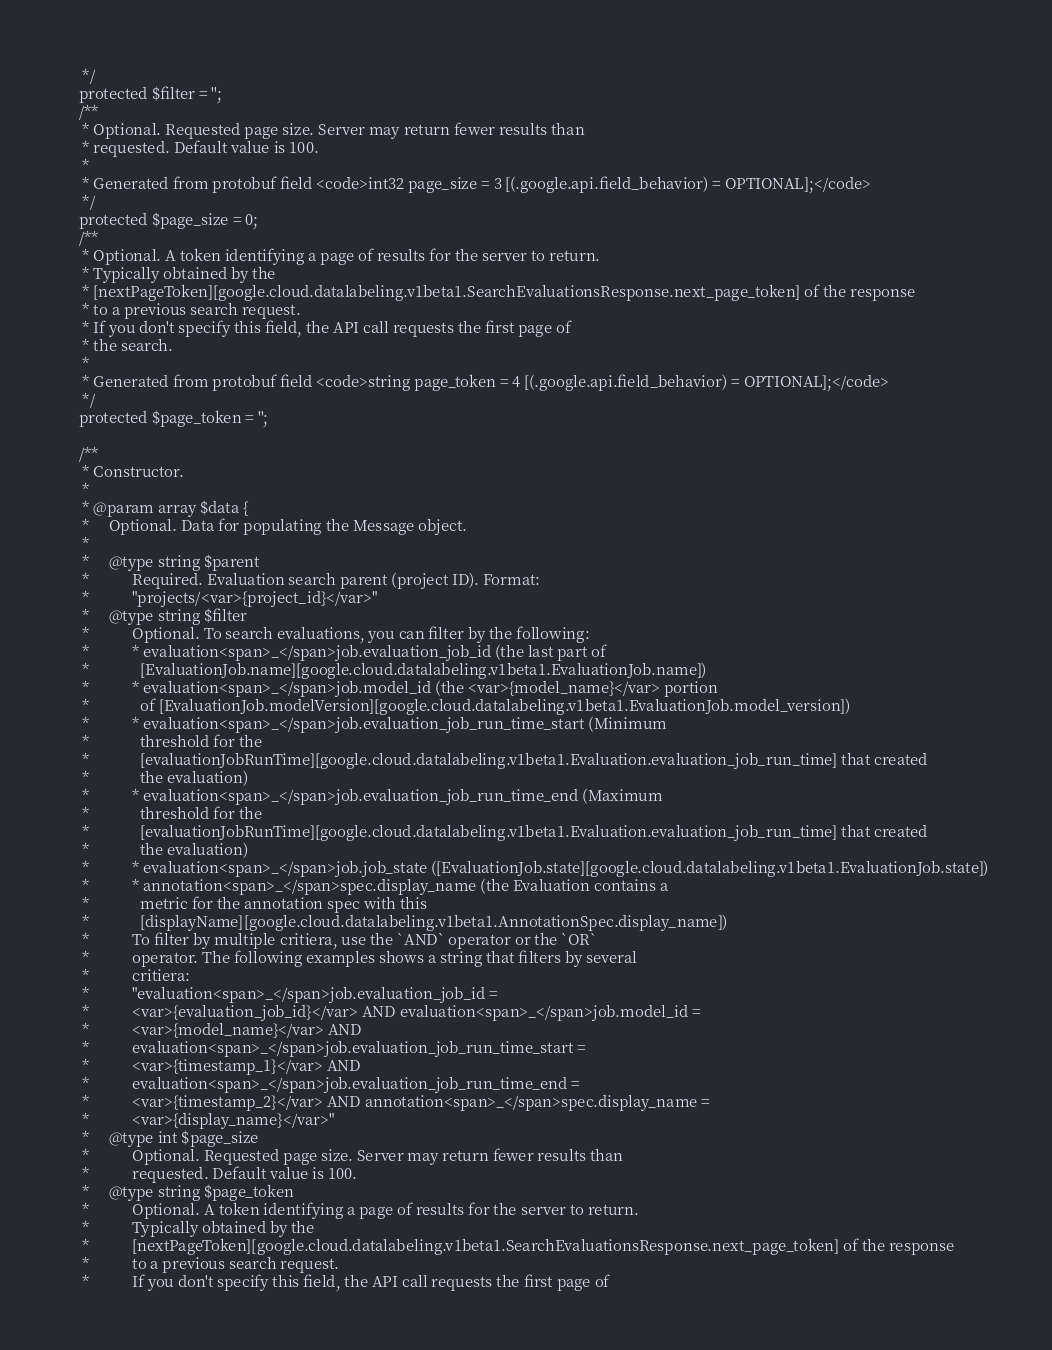Convert code to text. <code><loc_0><loc_0><loc_500><loc_500><_PHP_>     */
    protected $filter = '';
    /**
     * Optional. Requested page size. Server may return fewer results than
     * requested. Default value is 100.
     *
     * Generated from protobuf field <code>int32 page_size = 3 [(.google.api.field_behavior) = OPTIONAL];</code>
     */
    protected $page_size = 0;
    /**
     * Optional. A token identifying a page of results for the server to return.
     * Typically obtained by the
     * [nextPageToken][google.cloud.datalabeling.v1beta1.SearchEvaluationsResponse.next_page_token] of the response
     * to a previous search request.
     * If you don't specify this field, the API call requests the first page of
     * the search.
     *
     * Generated from protobuf field <code>string page_token = 4 [(.google.api.field_behavior) = OPTIONAL];</code>
     */
    protected $page_token = '';

    /**
     * Constructor.
     *
     * @param array $data {
     *     Optional. Data for populating the Message object.
     *
     *     @type string $parent
     *           Required. Evaluation search parent (project ID). Format:
     *           "projects/<var>{project_id}</var>"
     *     @type string $filter
     *           Optional. To search evaluations, you can filter by the following:
     *           * evaluation<span>_</span>job.evaluation_job_id (the last part of
     *             [EvaluationJob.name][google.cloud.datalabeling.v1beta1.EvaluationJob.name])
     *           * evaluation<span>_</span>job.model_id (the <var>{model_name}</var> portion
     *             of [EvaluationJob.modelVersion][google.cloud.datalabeling.v1beta1.EvaluationJob.model_version])
     *           * evaluation<span>_</span>job.evaluation_job_run_time_start (Minimum
     *             threshold for the
     *             [evaluationJobRunTime][google.cloud.datalabeling.v1beta1.Evaluation.evaluation_job_run_time] that created
     *             the evaluation)
     *           * evaluation<span>_</span>job.evaluation_job_run_time_end (Maximum
     *             threshold for the
     *             [evaluationJobRunTime][google.cloud.datalabeling.v1beta1.Evaluation.evaluation_job_run_time] that created
     *             the evaluation)
     *           * evaluation<span>_</span>job.job_state ([EvaluationJob.state][google.cloud.datalabeling.v1beta1.EvaluationJob.state])
     *           * annotation<span>_</span>spec.display_name (the Evaluation contains a
     *             metric for the annotation spec with this
     *             [displayName][google.cloud.datalabeling.v1beta1.AnnotationSpec.display_name])
     *           To filter by multiple critiera, use the `AND` operator or the `OR`
     *           operator. The following examples shows a string that filters by several
     *           critiera:
     *           "evaluation<span>_</span>job.evaluation_job_id =
     *           <var>{evaluation_job_id}</var> AND evaluation<span>_</span>job.model_id =
     *           <var>{model_name}</var> AND
     *           evaluation<span>_</span>job.evaluation_job_run_time_start =
     *           <var>{timestamp_1}</var> AND
     *           evaluation<span>_</span>job.evaluation_job_run_time_end =
     *           <var>{timestamp_2}</var> AND annotation<span>_</span>spec.display_name =
     *           <var>{display_name}</var>"
     *     @type int $page_size
     *           Optional. Requested page size. Server may return fewer results than
     *           requested. Default value is 100.
     *     @type string $page_token
     *           Optional. A token identifying a page of results for the server to return.
     *           Typically obtained by the
     *           [nextPageToken][google.cloud.datalabeling.v1beta1.SearchEvaluationsResponse.next_page_token] of the response
     *           to a previous search request.
     *           If you don't specify this field, the API call requests the first page of</code> 